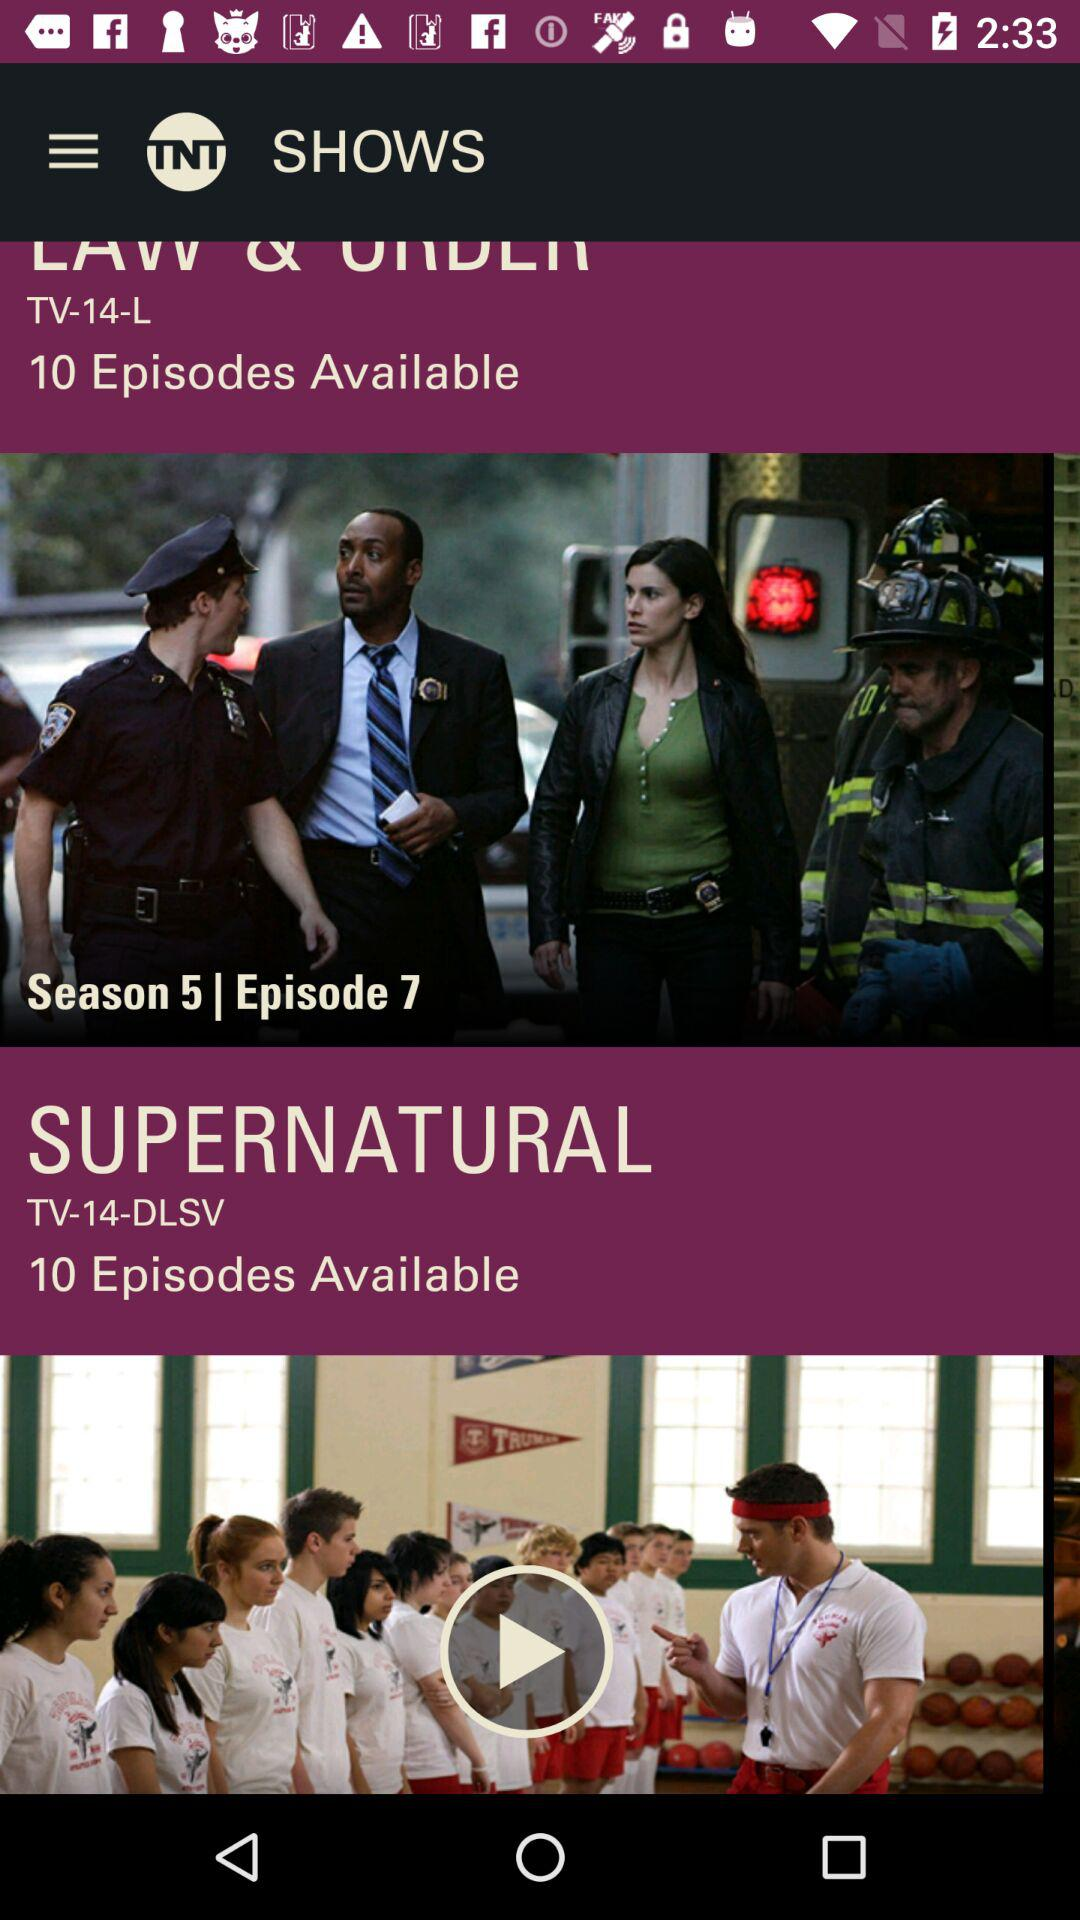How many episodes are available in season 5? There are ten episodes available in season five. 